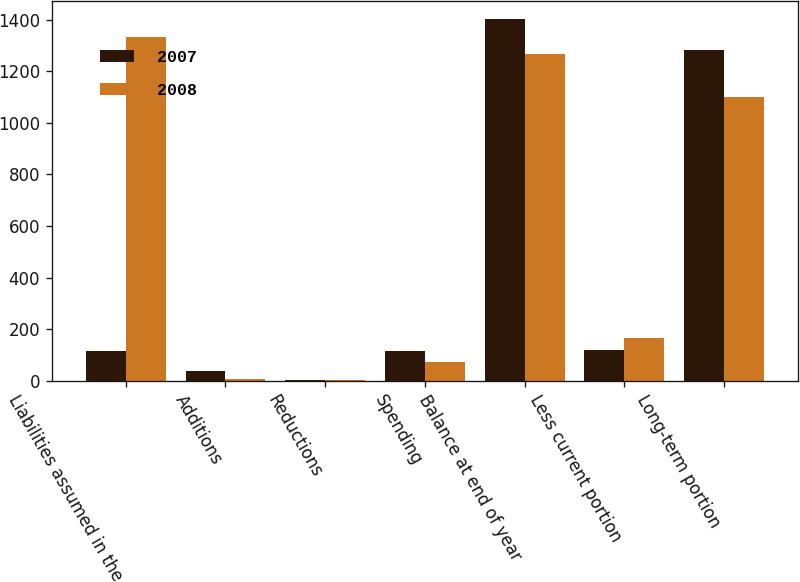Convert chart. <chart><loc_0><loc_0><loc_500><loc_500><stacked_bar_chart><ecel><fcel>Liabilities assumed in the<fcel>Additions<fcel>Reductions<fcel>Spending<fcel>Balance at end of year<fcel>Less current portion<fcel>Long-term portion<nl><fcel>2007<fcel>117<fcel>36<fcel>1<fcel>114<fcel>1401<fcel>120<fcel>1281<nl><fcel>2008<fcel>1334<fcel>6<fcel>1<fcel>71<fcel>1268<fcel>166<fcel>1102<nl></chart> 